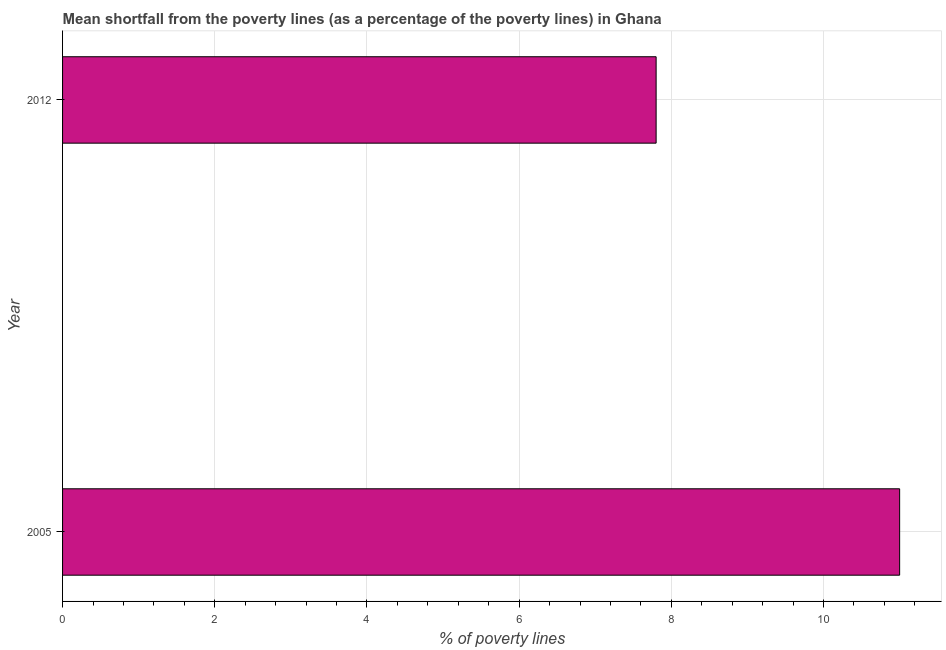Does the graph contain any zero values?
Offer a very short reply. No. Does the graph contain grids?
Your answer should be compact. Yes. What is the title of the graph?
Keep it short and to the point. Mean shortfall from the poverty lines (as a percentage of the poverty lines) in Ghana. What is the label or title of the X-axis?
Your response must be concise. % of poverty lines. What is the label or title of the Y-axis?
Give a very brief answer. Year. Across all years, what is the maximum poverty gap at national poverty lines?
Your answer should be very brief. 11. In which year was the poverty gap at national poverty lines minimum?
Your answer should be very brief. 2012. What is the sum of the poverty gap at national poverty lines?
Ensure brevity in your answer.  18.8. What is the difference between the poverty gap at national poverty lines in 2005 and 2012?
Keep it short and to the point. 3.2. In how many years, is the poverty gap at national poverty lines greater than 2 %?
Give a very brief answer. 2. What is the ratio of the poverty gap at national poverty lines in 2005 to that in 2012?
Give a very brief answer. 1.41. How many bars are there?
Make the answer very short. 2. Are all the bars in the graph horizontal?
Your answer should be compact. Yes. How many years are there in the graph?
Offer a very short reply. 2. Are the values on the major ticks of X-axis written in scientific E-notation?
Your answer should be compact. No. What is the % of poverty lines in 2005?
Give a very brief answer. 11. What is the ratio of the % of poverty lines in 2005 to that in 2012?
Offer a terse response. 1.41. 